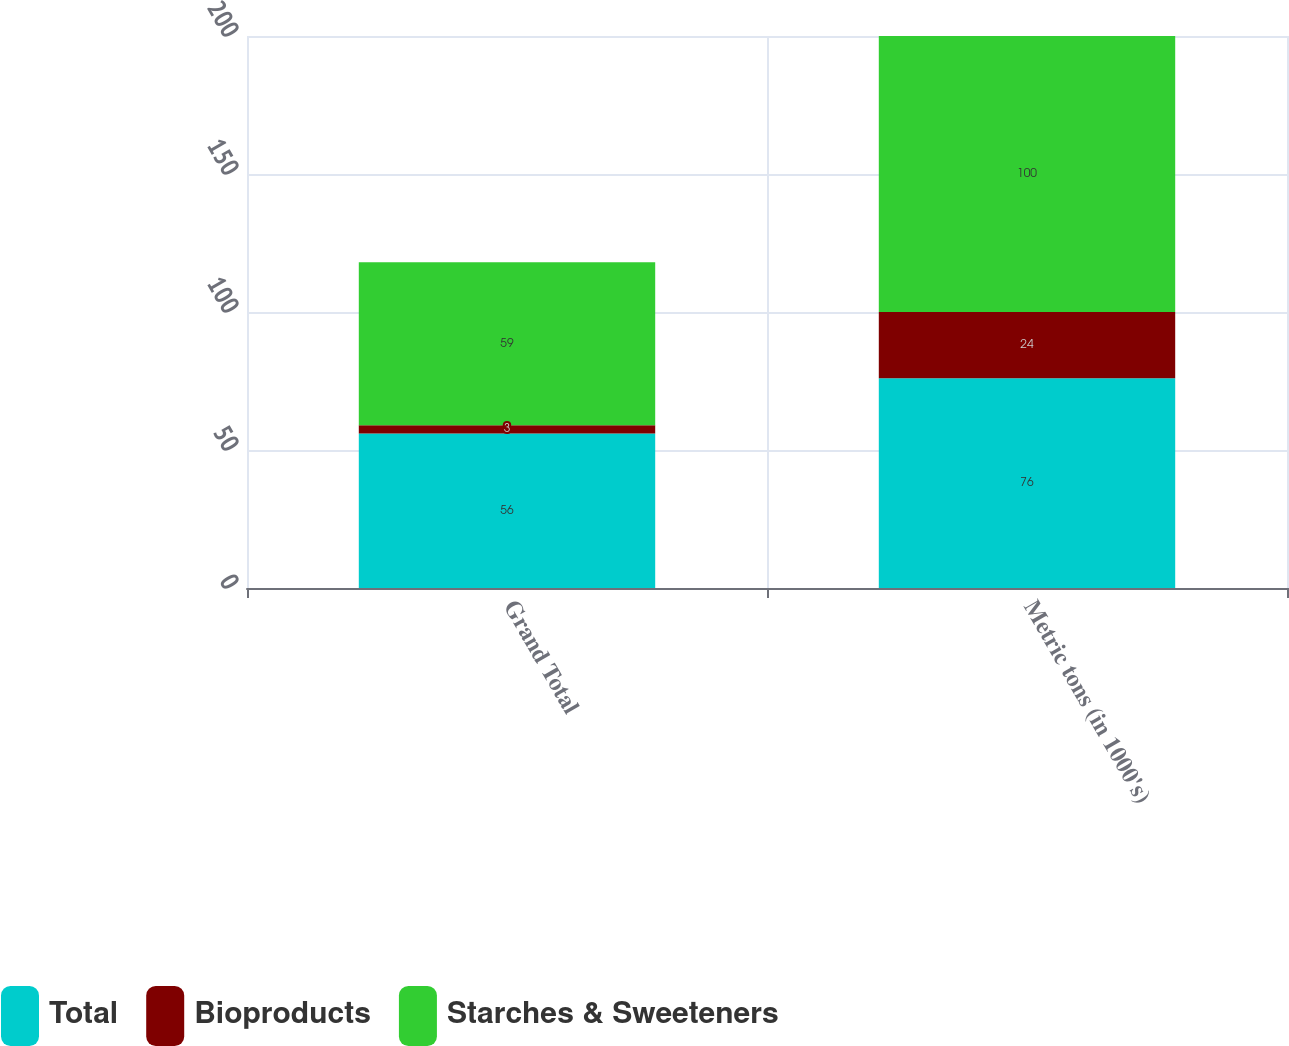<chart> <loc_0><loc_0><loc_500><loc_500><stacked_bar_chart><ecel><fcel>Grand Total<fcel>Metric tons (in 1000's)<nl><fcel>Total<fcel>56<fcel>76<nl><fcel>Bioproducts<fcel>3<fcel>24<nl><fcel>Starches & Sweeteners<fcel>59<fcel>100<nl></chart> 